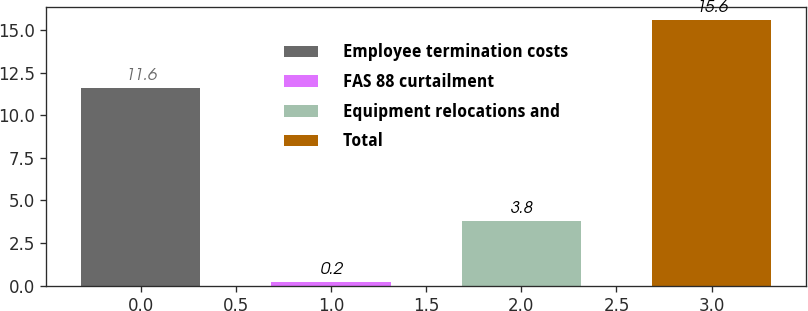Convert chart to OTSL. <chart><loc_0><loc_0><loc_500><loc_500><bar_chart><fcel>Employee termination costs<fcel>FAS 88 curtailment<fcel>Equipment relocations and<fcel>Total<nl><fcel>11.6<fcel>0.2<fcel>3.8<fcel>15.6<nl></chart> 